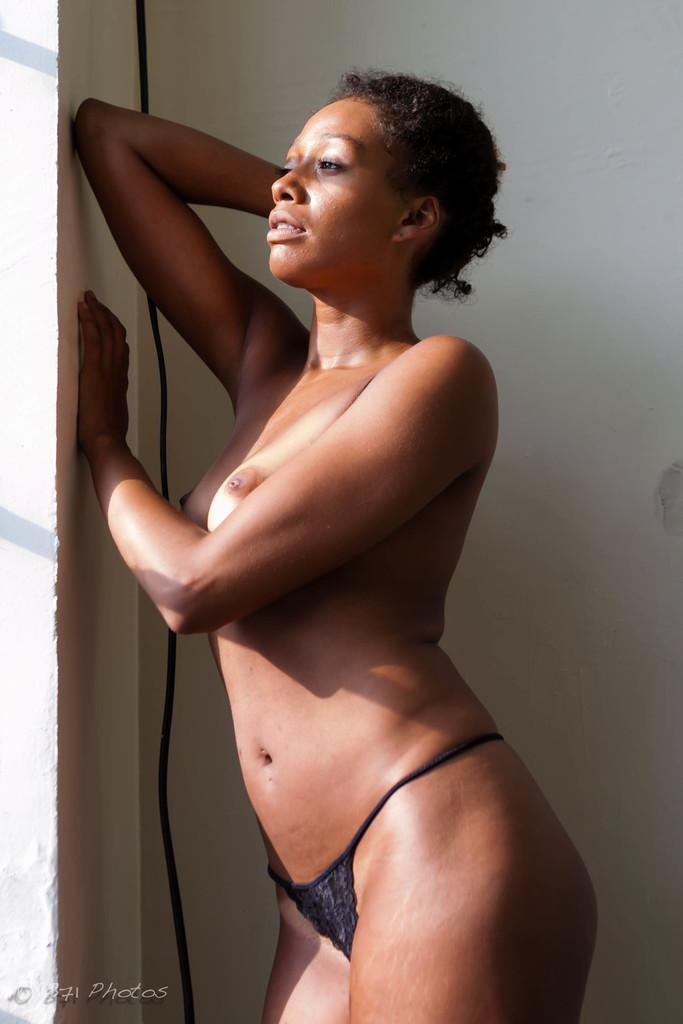What is the main subject of the image? There is a person standing in the image. What is the person wearing? The person is wearing a black dress. What can be seen in the background of the image? There is a white wall visible in the background of the image. What type of caption is written on the white wall in the image? There is no caption written on the white wall in the image. What kind of control can be seen in the person's hand in the image? There is no control visible in the person's hand in the image. 